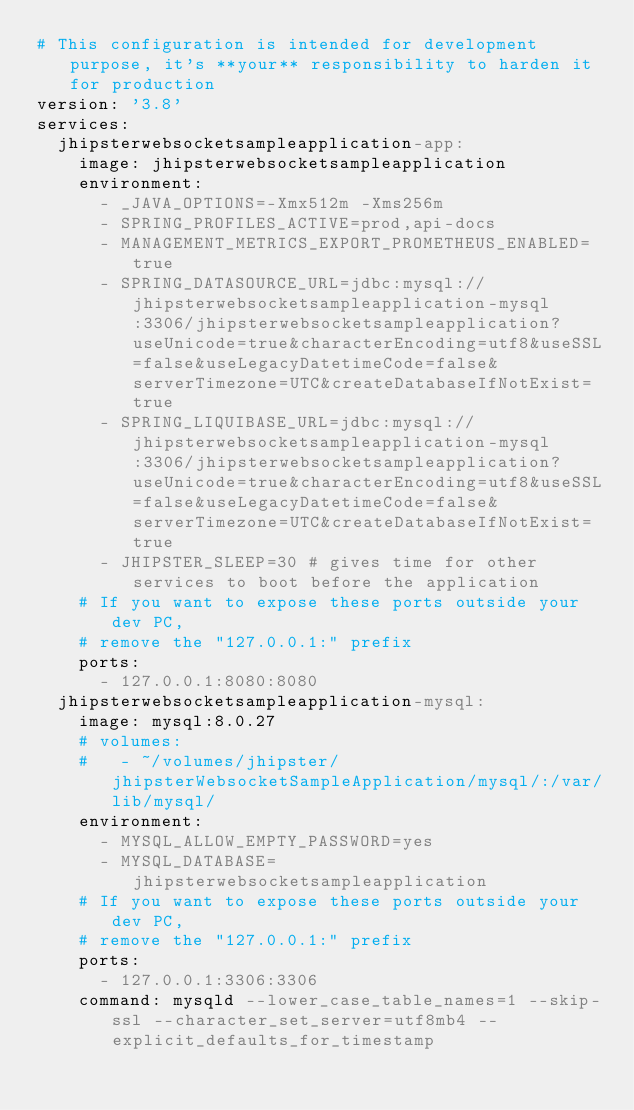<code> <loc_0><loc_0><loc_500><loc_500><_YAML_># This configuration is intended for development purpose, it's **your** responsibility to harden it for production
version: '3.8'
services:
  jhipsterwebsocketsampleapplication-app:
    image: jhipsterwebsocketsampleapplication
    environment:
      - _JAVA_OPTIONS=-Xmx512m -Xms256m
      - SPRING_PROFILES_ACTIVE=prod,api-docs
      - MANAGEMENT_METRICS_EXPORT_PROMETHEUS_ENABLED=true
      - SPRING_DATASOURCE_URL=jdbc:mysql://jhipsterwebsocketsampleapplication-mysql:3306/jhipsterwebsocketsampleapplication?useUnicode=true&characterEncoding=utf8&useSSL=false&useLegacyDatetimeCode=false&serverTimezone=UTC&createDatabaseIfNotExist=true
      - SPRING_LIQUIBASE_URL=jdbc:mysql://jhipsterwebsocketsampleapplication-mysql:3306/jhipsterwebsocketsampleapplication?useUnicode=true&characterEncoding=utf8&useSSL=false&useLegacyDatetimeCode=false&serverTimezone=UTC&createDatabaseIfNotExist=true
      - JHIPSTER_SLEEP=30 # gives time for other services to boot before the application
    # If you want to expose these ports outside your dev PC,
    # remove the "127.0.0.1:" prefix
    ports:
      - 127.0.0.1:8080:8080
  jhipsterwebsocketsampleapplication-mysql:
    image: mysql:8.0.27
    # volumes:
    #   - ~/volumes/jhipster/jhipsterWebsocketSampleApplication/mysql/:/var/lib/mysql/
    environment:
      - MYSQL_ALLOW_EMPTY_PASSWORD=yes
      - MYSQL_DATABASE=jhipsterwebsocketsampleapplication
    # If you want to expose these ports outside your dev PC,
    # remove the "127.0.0.1:" prefix
    ports:
      - 127.0.0.1:3306:3306
    command: mysqld --lower_case_table_names=1 --skip-ssl --character_set_server=utf8mb4 --explicit_defaults_for_timestamp
</code> 